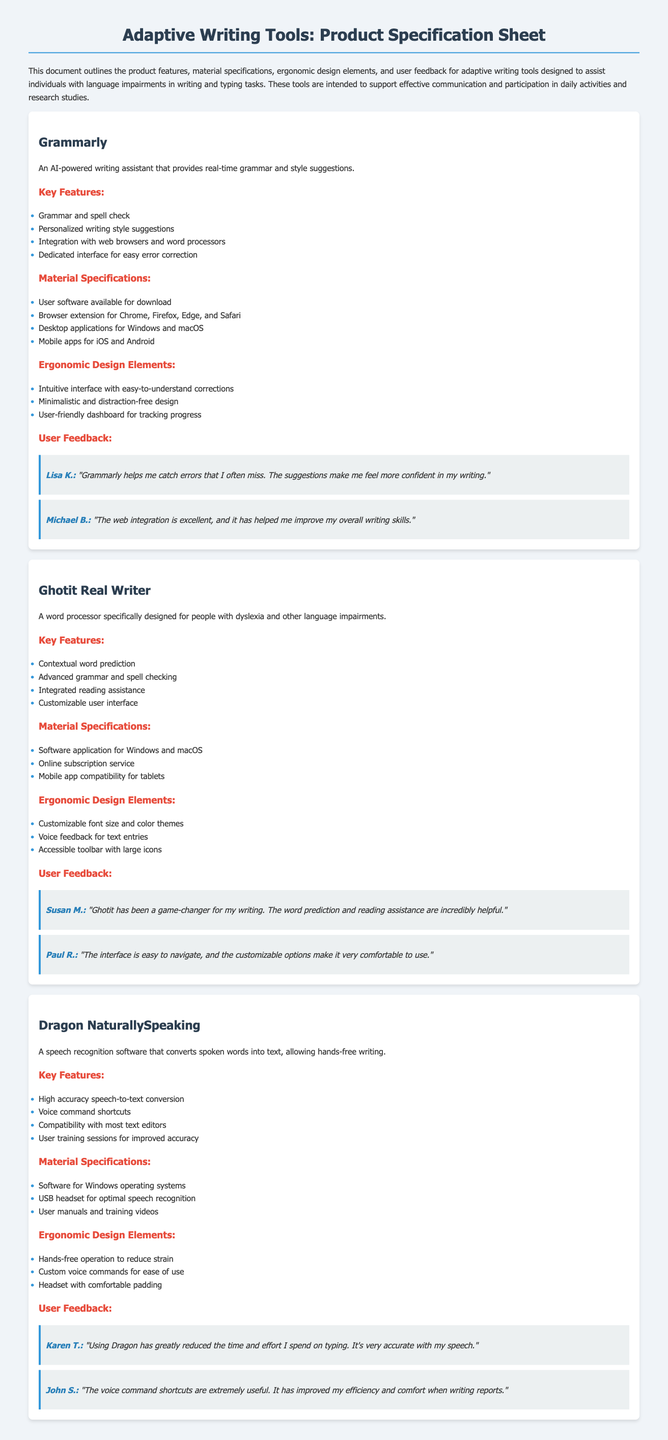what is the name of the first product? The first product listed in the document is "Grammarly."
Answer: Grammarly what feature does Ghotit Real Writer provide for users with language impairments? Ghotit Real Writer provides "contextual word prediction" for users, helping them in writing.
Answer: contextual word prediction which platforms is Dragon NaturallySpeaking compatible with? According to the document, Dragon NaturallySpeaking is compatible with "most text editors."
Answer: most text editors how many user feedback quotes are provided for Grammarly? The document includes two user feedback quotes for Grammarly.
Answer: 2 what additional assistance does Ghotit Real Writer offer aside from writing? Ghotit Real Writer offers "integrated reading assistance" to support users beyond just writing tasks.
Answer: integrated reading assistance what type of tool is Dragon NaturallySpeaking classified as? Dragon NaturallySpeaking is classified as "speech recognition software."
Answer: speech recognition software which ergonomic design element is highlighted for Grammarly? The ergonomic design element highlighted for Grammarly is its "minimalistic and distraction-free design."
Answer: minimalistic and distraction-free design how does Karen T. feel about using Dragon NaturallySpeaking? Karen T. feels that using Dragon NaturallySpeaking has "greatly reduced the time and effort" on typing tasks.
Answer: greatly reduced the time and effort 